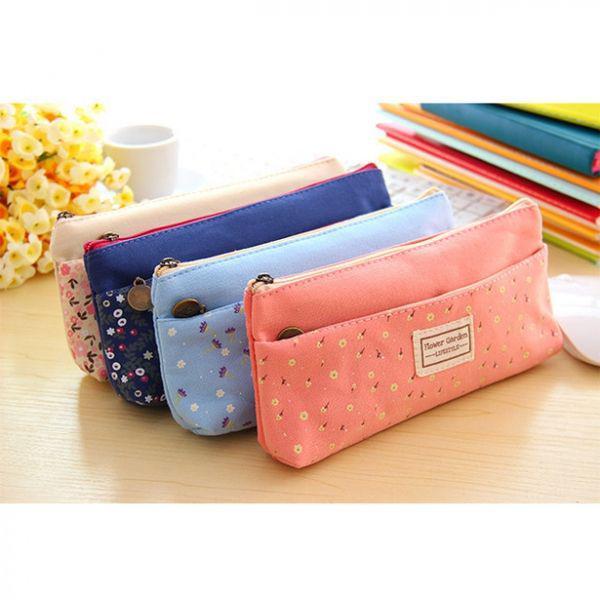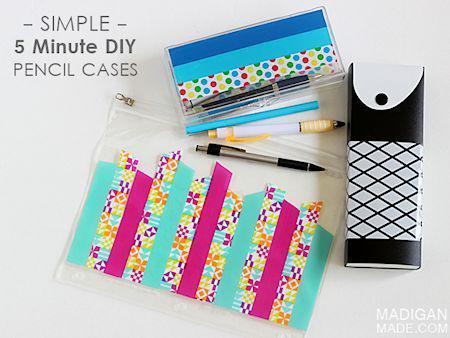The first image is the image on the left, the second image is the image on the right. For the images shown, is this caption "box shaped pencil holders are folded open" true? Answer yes or no. No. The first image is the image on the left, the second image is the image on the right. For the images displayed, is the sentence "The left image contains only closed containers, the right has one open with multiple pencils inside." factually correct? Answer yes or no. No. 